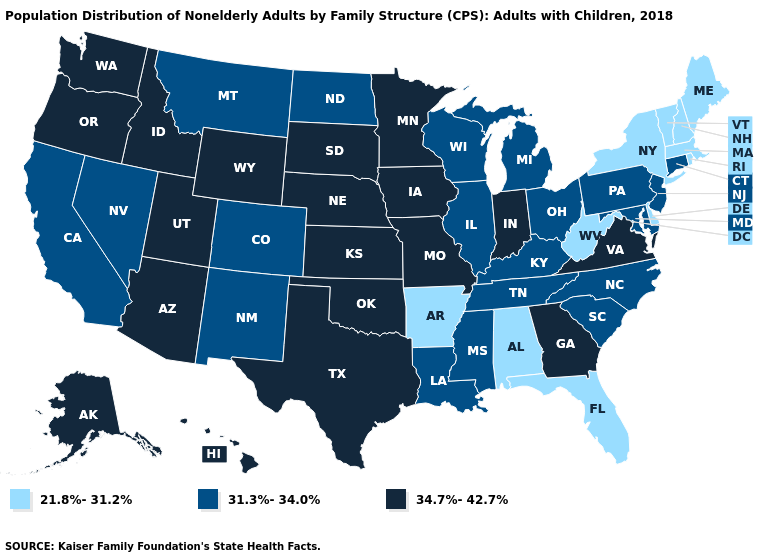Among the states that border California , which have the lowest value?
Keep it brief. Nevada. Which states have the highest value in the USA?
Keep it brief. Alaska, Arizona, Georgia, Hawaii, Idaho, Indiana, Iowa, Kansas, Minnesota, Missouri, Nebraska, Oklahoma, Oregon, South Dakota, Texas, Utah, Virginia, Washington, Wyoming. What is the value of Alabama?
Short answer required. 21.8%-31.2%. Does Florida have the lowest value in the South?
Give a very brief answer. Yes. Which states have the highest value in the USA?
Give a very brief answer. Alaska, Arizona, Georgia, Hawaii, Idaho, Indiana, Iowa, Kansas, Minnesota, Missouri, Nebraska, Oklahoma, Oregon, South Dakota, Texas, Utah, Virginia, Washington, Wyoming. Among the states that border Delaware , which have the highest value?
Be succinct. Maryland, New Jersey, Pennsylvania. Does Missouri have the lowest value in the MidWest?
Short answer required. No. Which states have the lowest value in the USA?
Concise answer only. Alabama, Arkansas, Delaware, Florida, Maine, Massachusetts, New Hampshire, New York, Rhode Island, Vermont, West Virginia. Name the states that have a value in the range 34.7%-42.7%?
Be succinct. Alaska, Arizona, Georgia, Hawaii, Idaho, Indiana, Iowa, Kansas, Minnesota, Missouri, Nebraska, Oklahoma, Oregon, South Dakota, Texas, Utah, Virginia, Washington, Wyoming. Name the states that have a value in the range 34.7%-42.7%?
Short answer required. Alaska, Arizona, Georgia, Hawaii, Idaho, Indiana, Iowa, Kansas, Minnesota, Missouri, Nebraska, Oklahoma, Oregon, South Dakota, Texas, Utah, Virginia, Washington, Wyoming. What is the highest value in states that border Texas?
Write a very short answer. 34.7%-42.7%. What is the lowest value in states that border California?
Keep it brief. 31.3%-34.0%. What is the lowest value in states that border Wisconsin?
Keep it brief. 31.3%-34.0%. What is the lowest value in the USA?
Write a very short answer. 21.8%-31.2%. What is the highest value in states that border Rhode Island?
Be succinct. 31.3%-34.0%. 